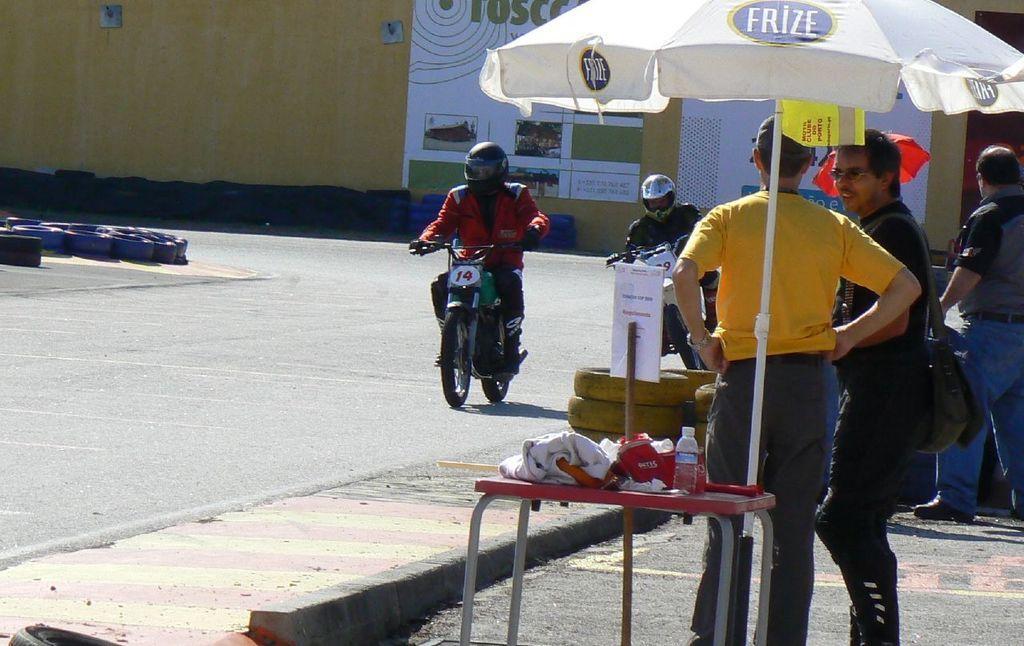In one or two sentences, can you explain what this image depicts? This image is clicked outside. There is a motorcycle and a person is sitting on it. He is wearing helmet. There is umbrella and a table is under that. There are water bottle, clothes and Cap on that table. People are standing near that umbrella. There are tyres on the left side. 